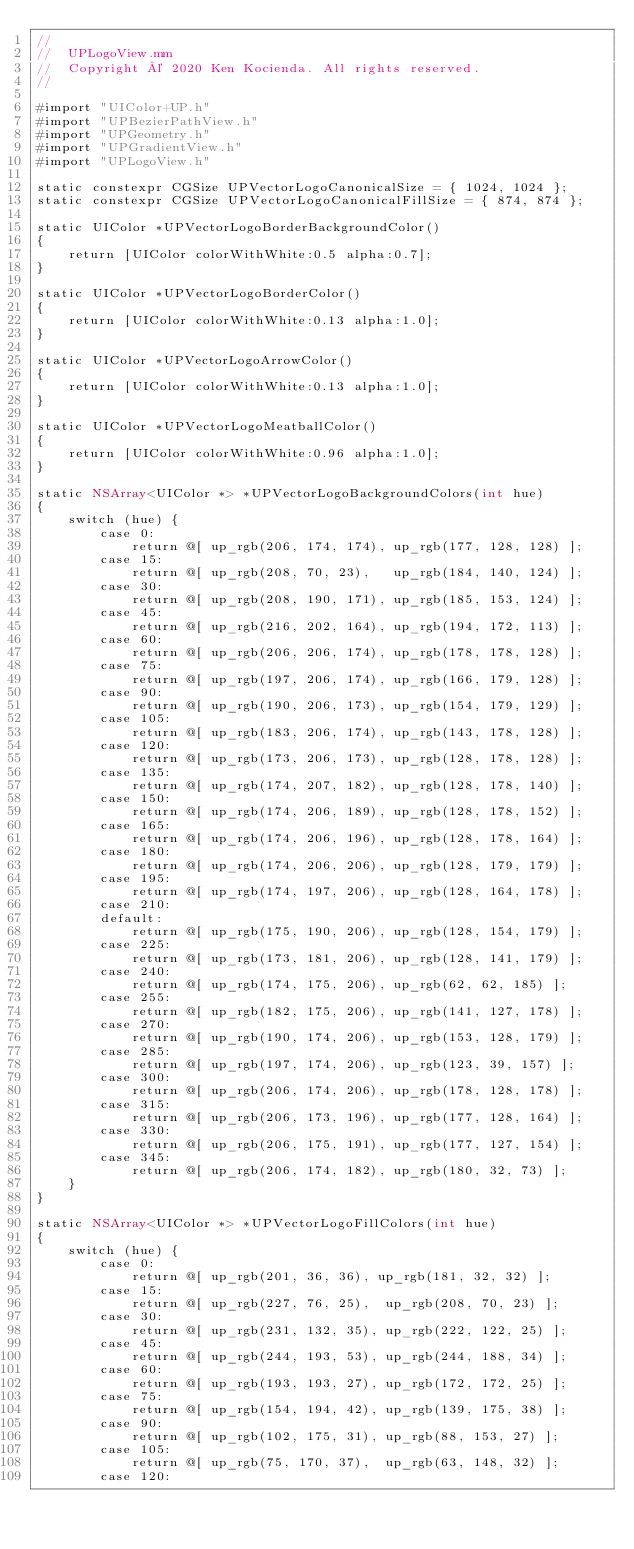Convert code to text. <code><loc_0><loc_0><loc_500><loc_500><_ObjectiveC_>//
//  UPLogoView.mm
//  Copyright © 2020 Ken Kocienda. All rights reserved.
//

#import "UIColor+UP.h"
#import "UPBezierPathView.h"
#import "UPGeometry.h"
#import "UPGradientView.h"
#import "UPLogoView.h"

static constexpr CGSize UPVectorLogoCanonicalSize = { 1024, 1024 };
static constexpr CGSize UPVectorLogoCanonicalFillSize = { 874, 874 };

static UIColor *UPVectorLogoBorderBackgroundColor()
{
    return [UIColor colorWithWhite:0.5 alpha:0.7];
}

static UIColor *UPVectorLogoBorderColor()
{
    return [UIColor colorWithWhite:0.13 alpha:1.0];
}

static UIColor *UPVectorLogoArrowColor()
{
    return [UIColor colorWithWhite:0.13 alpha:1.0];
}

static UIColor *UPVectorLogoMeatballColor()
{
    return [UIColor colorWithWhite:0.96 alpha:1.0];
}

static NSArray<UIColor *> *UPVectorLogoBackgroundColors(int hue)
{
    switch (hue) {
        case 0:
            return @[ up_rgb(206, 174, 174), up_rgb(177, 128, 128) ];
        case 15:
            return @[ up_rgb(208, 70, 23),   up_rgb(184, 140, 124) ];
        case 30:
            return @[ up_rgb(208, 190, 171), up_rgb(185, 153, 124) ];
        case 45:
            return @[ up_rgb(216, 202, 164), up_rgb(194, 172, 113) ];
        case 60:
            return @[ up_rgb(206, 206, 174), up_rgb(178, 178, 128) ];
        case 75:
            return @[ up_rgb(197, 206, 174), up_rgb(166, 179, 128) ];
        case 90:
            return @[ up_rgb(190, 206, 173), up_rgb(154, 179, 129) ];
        case 105:
            return @[ up_rgb(183, 206, 174), up_rgb(143, 178, 128) ];
        case 120:
            return @[ up_rgb(173, 206, 173), up_rgb(128, 178, 128) ];
        case 135:
            return @[ up_rgb(174, 207, 182), up_rgb(128, 178, 140) ];
        case 150:
            return @[ up_rgb(174, 206, 189), up_rgb(128, 178, 152) ];
        case 165:
            return @[ up_rgb(174, 206, 196), up_rgb(128, 178, 164) ];
        case 180:
            return @[ up_rgb(174, 206, 206), up_rgb(128, 179, 179) ];
        case 195:
            return @[ up_rgb(174, 197, 206), up_rgb(128, 164, 178) ];
        case 210:
        default:
            return @[ up_rgb(175, 190, 206), up_rgb(128, 154, 179) ];
        case 225:
            return @[ up_rgb(173, 181, 206), up_rgb(128, 141, 179) ];
        case 240:
            return @[ up_rgb(174, 175, 206), up_rgb(62, 62, 185) ];
        case 255:
            return @[ up_rgb(182, 175, 206), up_rgb(141, 127, 178) ];
        case 270:
            return @[ up_rgb(190, 174, 206), up_rgb(153, 128, 179) ];
        case 285:
            return @[ up_rgb(197, 174, 206), up_rgb(123, 39, 157) ];
        case 300:
            return @[ up_rgb(206, 174, 206), up_rgb(178, 128, 178) ];
        case 315:
            return @[ up_rgb(206, 173, 196), up_rgb(177, 128, 164) ];
        case 330:
            return @[ up_rgb(206, 175, 191), up_rgb(177, 127, 154) ];
        case 345:
            return @[ up_rgb(206, 174, 182), up_rgb(180, 32, 73) ];
    }
}

static NSArray<UIColor *> *UPVectorLogoFillColors(int hue)
{
    switch (hue) {
        case 0:
            return @[ up_rgb(201, 36, 36), up_rgb(181, 32, 32) ];
        case 15:
            return @[ up_rgb(227, 76, 25),  up_rgb(208, 70, 23) ];
        case 30:
            return @[ up_rgb(231, 132, 35), up_rgb(222, 122, 25) ];
        case 45:
            return @[ up_rgb(244, 193, 53), up_rgb(244, 188, 34) ];
        case 60:
            return @[ up_rgb(193, 193, 27), up_rgb(172, 172, 25) ];
        case 75:
            return @[ up_rgb(154, 194, 42), up_rgb(139, 175, 38) ];
        case 90:
            return @[ up_rgb(102, 175, 31), up_rgb(88, 153, 27) ];
        case 105:
            return @[ up_rgb(75, 170, 37),  up_rgb(63, 148, 32) ];
        case 120:</code> 